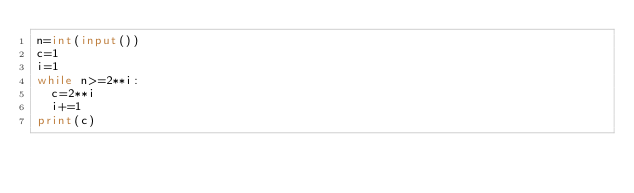<code> <loc_0><loc_0><loc_500><loc_500><_Python_>n=int(input())
c=1
i=1
while n>=2**i:
  c=2**i
  i+=1
print(c)</code> 